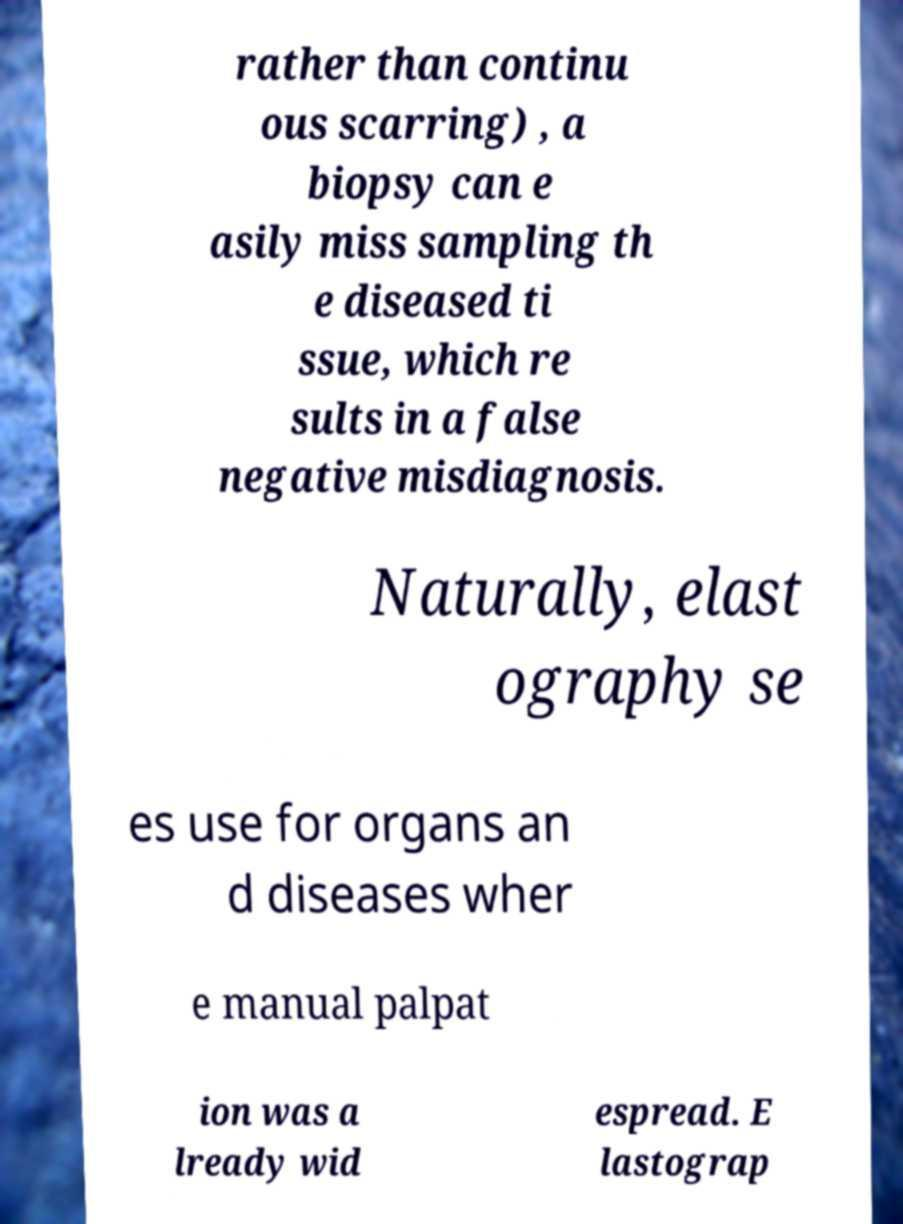I need the written content from this picture converted into text. Can you do that? rather than continu ous scarring) , a biopsy can e asily miss sampling th e diseased ti ssue, which re sults in a false negative misdiagnosis. Naturally, elast ography se es use for organs an d diseases wher e manual palpat ion was a lready wid espread. E lastograp 